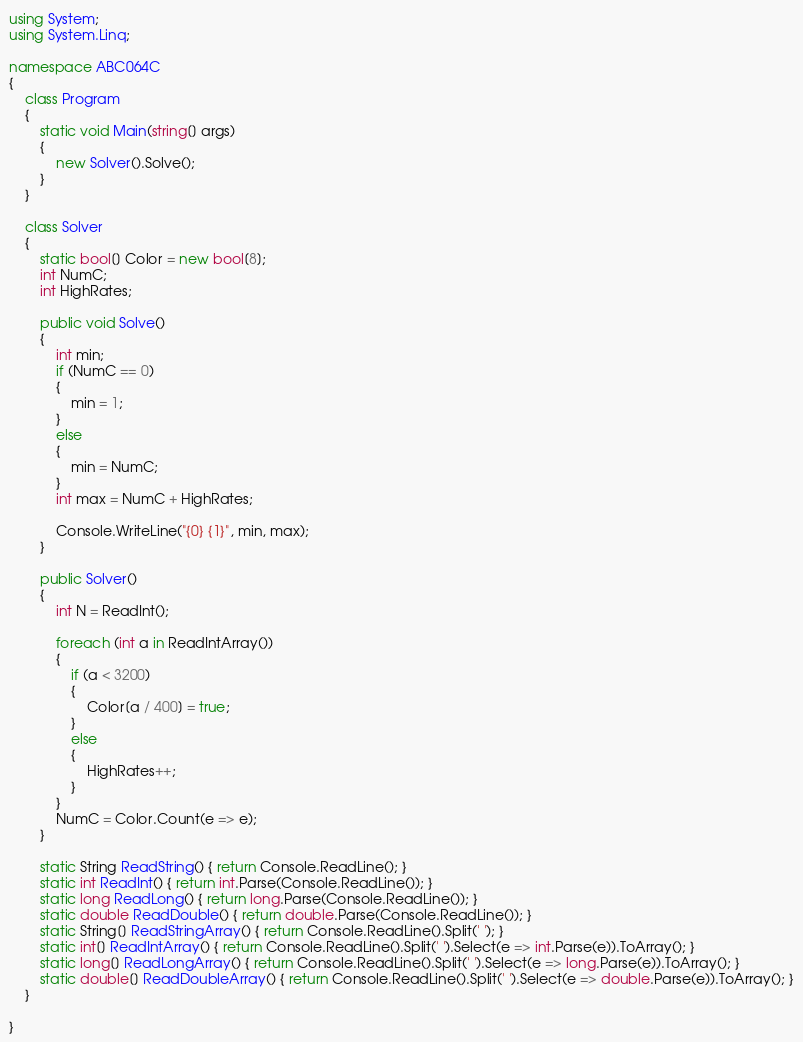Convert code to text. <code><loc_0><loc_0><loc_500><loc_500><_C#_>using System;
using System.Linq;

namespace ABC064C
{
    class Program
    {
        static void Main(string[] args)
        {
            new Solver().Solve();
        }
    }

    class Solver
    {
        static bool[] Color = new bool[8];
        int NumC;
        int HighRates;

        public void Solve()
        {
            int min;
            if (NumC == 0)
            {
                min = 1;
            }
            else
            {
                min = NumC;
            }
            int max = NumC + HighRates;

            Console.WriteLine("{0} {1}", min, max);
        }

        public Solver()
        {
            int N = ReadInt();

            foreach (int a in ReadIntArray())
            {
                if (a < 3200)
                {
                    Color[a / 400] = true;
                }
                else
                {
                    HighRates++;
                }
            }
            NumC = Color.Count(e => e);
        }

        static String ReadString() { return Console.ReadLine(); }
        static int ReadInt() { return int.Parse(Console.ReadLine()); }
        static long ReadLong() { return long.Parse(Console.ReadLine()); }
        static double ReadDouble() { return double.Parse(Console.ReadLine()); }
        static String[] ReadStringArray() { return Console.ReadLine().Split(' '); }
        static int[] ReadIntArray() { return Console.ReadLine().Split(' ').Select(e => int.Parse(e)).ToArray(); }
        static long[] ReadLongArray() { return Console.ReadLine().Split(' ').Select(e => long.Parse(e)).ToArray(); }
        static double[] ReadDoubleArray() { return Console.ReadLine().Split(' ').Select(e => double.Parse(e)).ToArray(); }
    }

}
</code> 